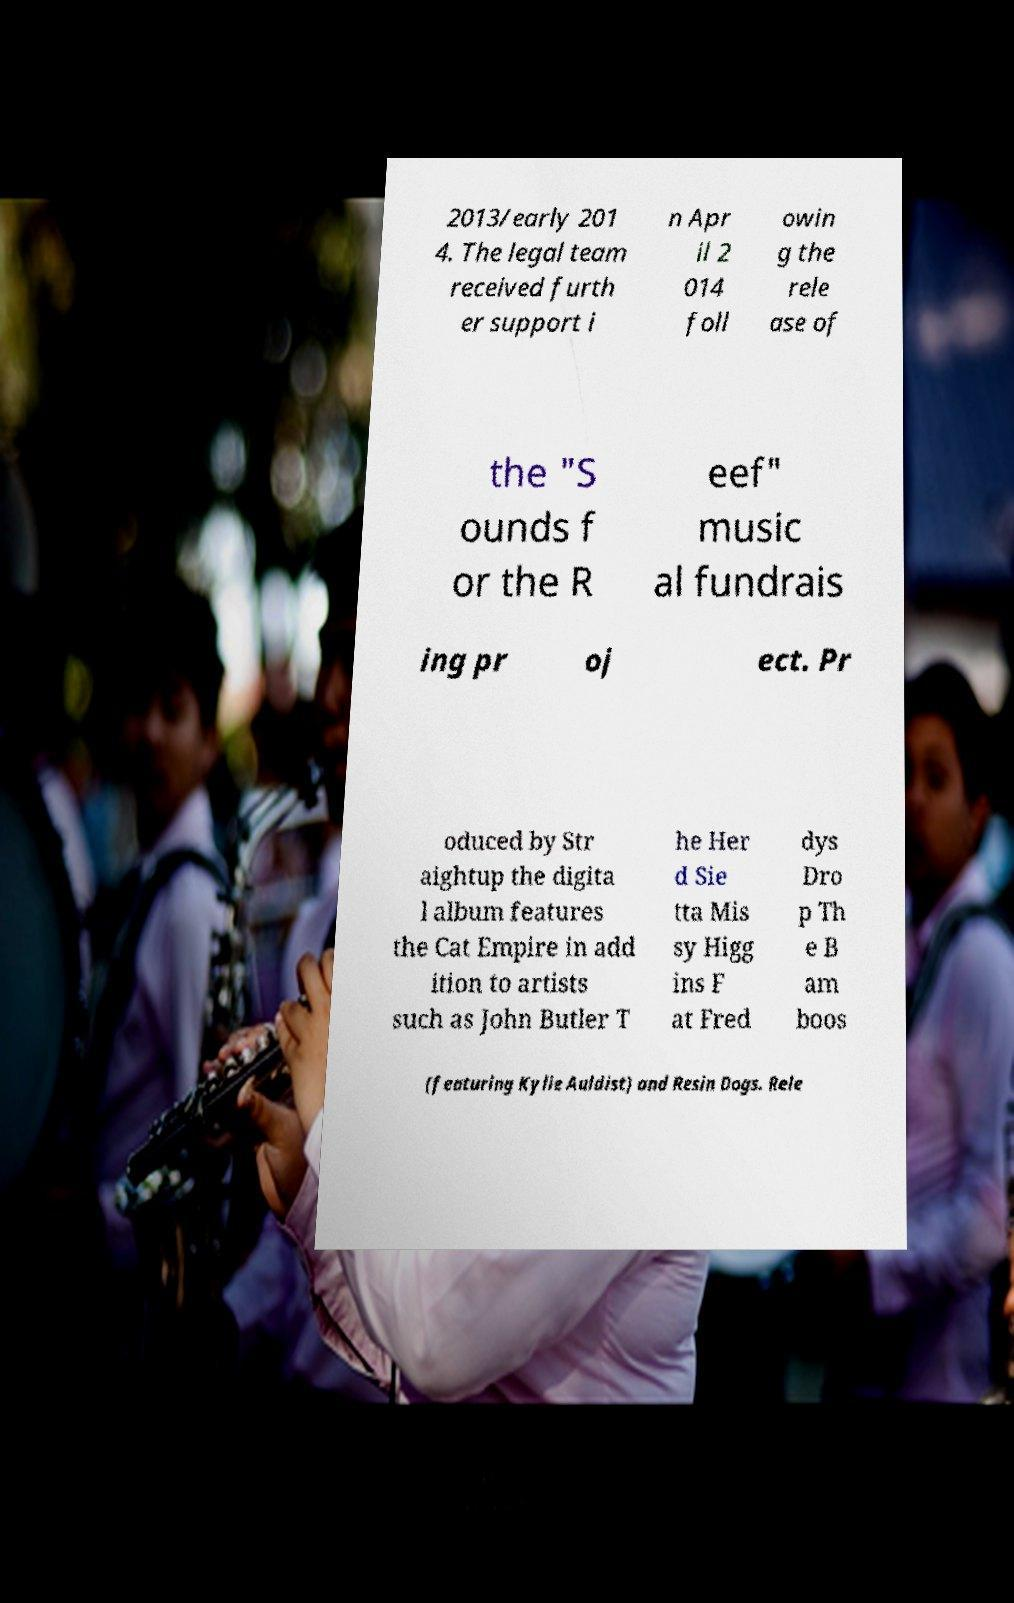There's text embedded in this image that I need extracted. Can you transcribe it verbatim? 2013/early 201 4. The legal team received furth er support i n Apr il 2 014 foll owin g the rele ase of the "S ounds f or the R eef" music al fundrais ing pr oj ect. Pr oduced by Str aightup the digita l album features the Cat Empire in add ition to artists such as John Butler T he Her d Sie tta Mis sy Higg ins F at Fred dys Dro p Th e B am boos (featuring Kylie Auldist) and Resin Dogs. Rele 